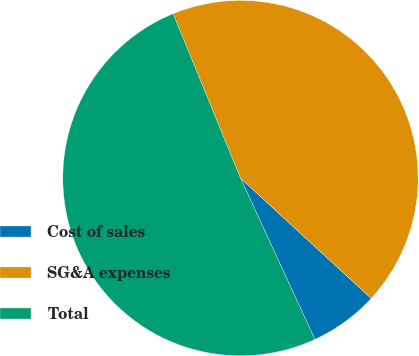Convert chart to OTSL. <chart><loc_0><loc_0><loc_500><loc_500><pie_chart><fcel>Cost of sales<fcel>SG&A expenses<fcel>Total<nl><fcel>6.28%<fcel>43.03%<fcel>50.69%<nl></chart> 